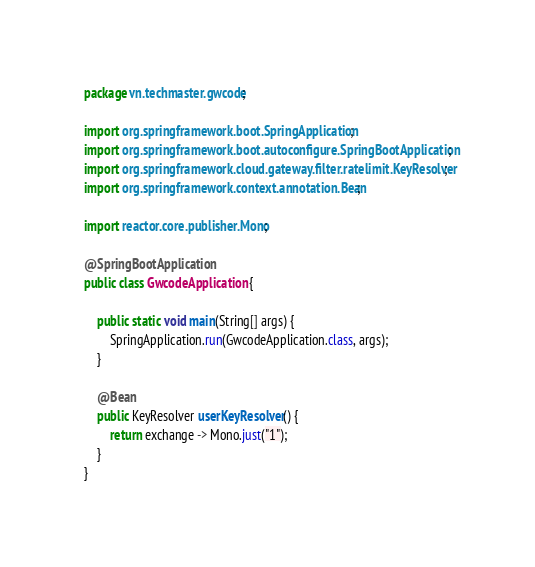<code> <loc_0><loc_0><loc_500><loc_500><_Java_>package vn.techmaster.gwcode;

import org.springframework.boot.SpringApplication;
import org.springframework.boot.autoconfigure.SpringBootApplication;
import org.springframework.cloud.gateway.filter.ratelimit.KeyResolver;
import org.springframework.context.annotation.Bean;

import reactor.core.publisher.Mono;

@SpringBootApplication
public class GwcodeApplication {

	public static void main(String[] args) {
		SpringApplication.run(GwcodeApplication.class, args);
	}

	@Bean
	public KeyResolver userKeyResolver() {
		return exchange -> Mono.just("1");
	}
}
</code> 